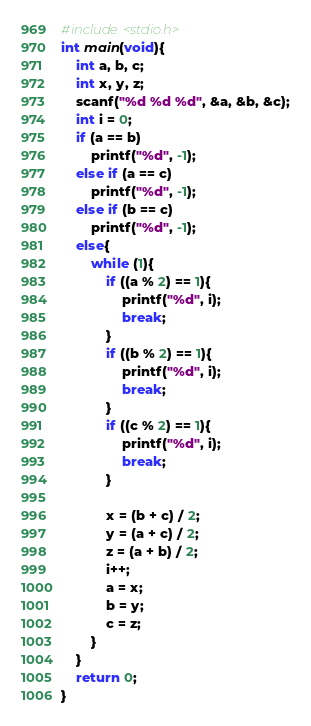<code> <loc_0><loc_0><loc_500><loc_500><_C_>#include<stdio.h>
int main(void){
	int a, b, c;
	int x, y, z;
	scanf("%d %d %d", &a, &b, &c);
	int i = 0;
	if (a == b)
		printf("%d", -1);
	else if (a == c)
		printf("%d", -1);
	else if (b == c)
		printf("%d", -1);
	else{
		while (1){
			if ((a % 2) == 1){
				printf("%d", i);
				break;
			}
			if ((b % 2) == 1){
				printf("%d", i);
				break;
			}
			if ((c % 2) == 1){
				printf("%d", i);
				break;
			}

			x = (b + c) / 2;
			y = (a + c) / 2;
			z = (a + b) / 2;
			i++;
			a = x;
			b = y;
			c = z;
		}
	}
	return 0;
}</code> 